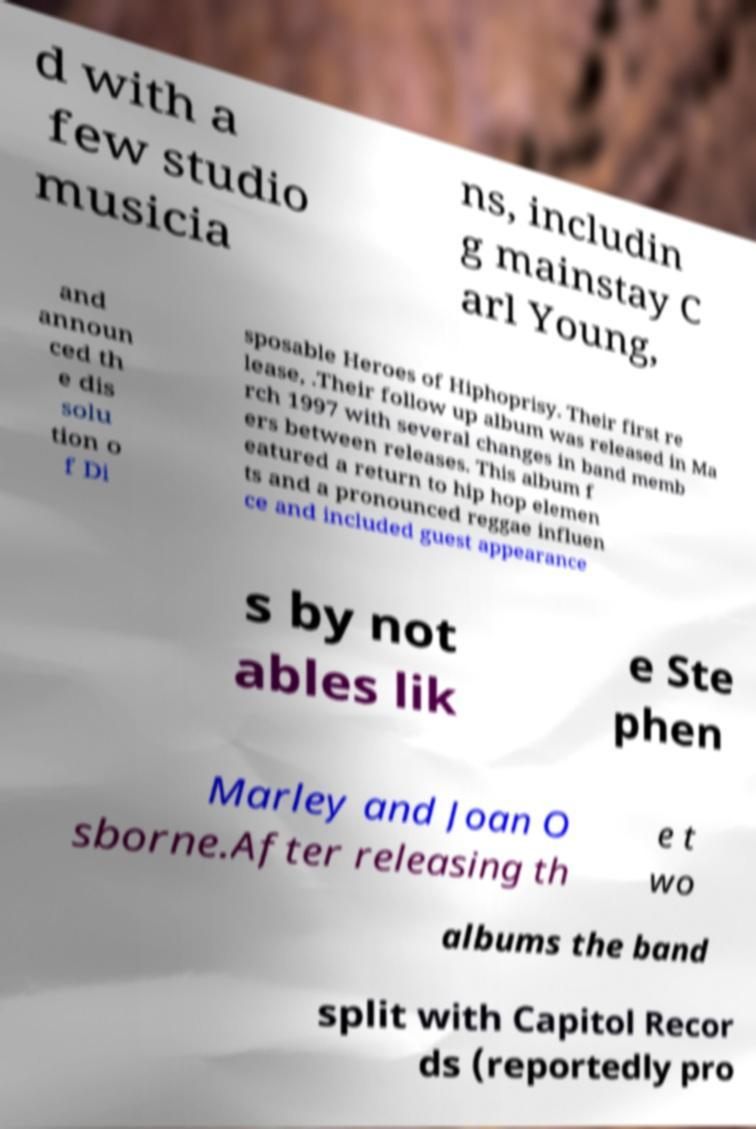There's text embedded in this image that I need extracted. Can you transcribe it verbatim? d with a few studio musicia ns, includin g mainstay C arl Young, and announ ced th e dis solu tion o f Di sposable Heroes of Hiphoprisy. Their first re lease, .Their follow up album was released in Ma rch 1997 with several changes in band memb ers between releases. This album f eatured a return to hip hop elemen ts and a pronounced reggae influen ce and included guest appearance s by not ables lik e Ste phen Marley and Joan O sborne.After releasing th e t wo albums the band split with Capitol Recor ds (reportedly pro 